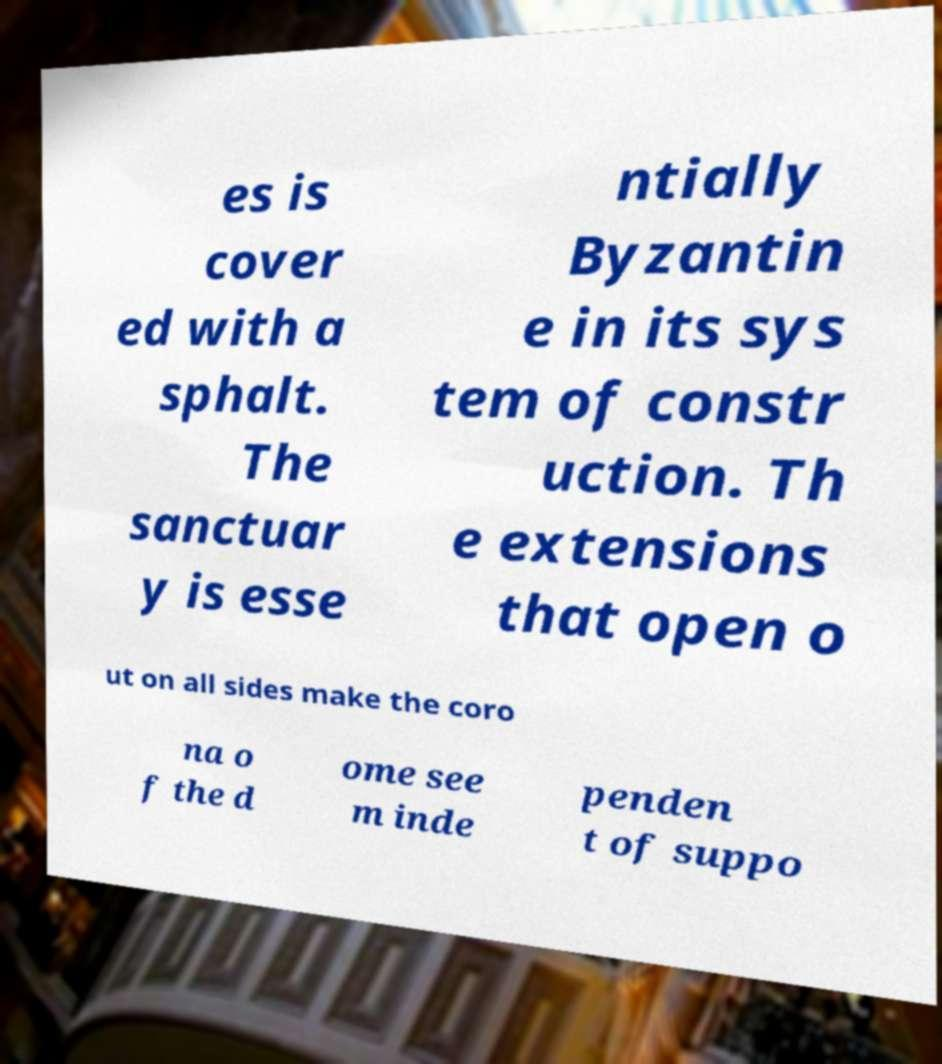Could you assist in decoding the text presented in this image and type it out clearly? es is cover ed with a sphalt. The sanctuar y is esse ntially Byzantin e in its sys tem of constr uction. Th e extensions that open o ut on all sides make the coro na o f the d ome see m inde penden t of suppo 